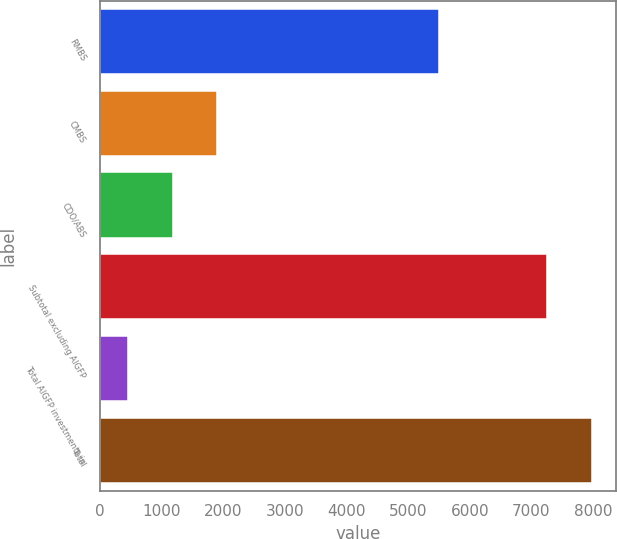Convert chart. <chart><loc_0><loc_0><loc_500><loc_500><bar_chart><fcel>RMBS<fcel>CMBS<fcel>CDO/ABS<fcel>Subtotal excluding AIGFP<fcel>Total AIGFP investments in<fcel>Total<nl><fcel>5504<fcel>1900.6<fcel>1175.3<fcel>7253<fcel>450<fcel>7978.3<nl></chart> 